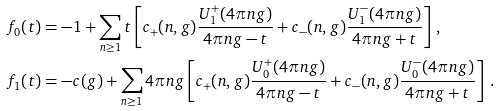Convert formula to latex. <formula><loc_0><loc_0><loc_500><loc_500>f _ { 0 } ( t ) & = - 1 + \sum _ { n \geq 1 } t \left [ { c _ { + } ( n , g ) } \frac { U _ { 1 } ^ { + } ( 4 \pi n g ) } { 4 \pi n g - t } + { c _ { - } ( n , g ) } \frac { U _ { 1 } ^ { - } ( 4 \pi n g ) } { 4 \pi n g + t } \right ] \, , \\ f _ { 1 } ( t ) & = - c ( g ) + \sum _ { n \geq 1 } 4 \pi n g \left [ { c _ { + } ( n , g ) } \frac { U _ { 0 } ^ { + } ( 4 \pi n g ) } { 4 \pi n g - t } + { c _ { - } ( n , g ) } \frac { U _ { 0 } ^ { - } ( 4 \pi n g ) } { 4 \pi n g + t } \right ] \, .</formula> 